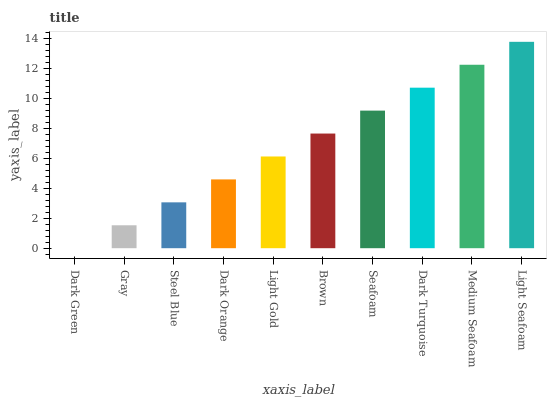Is Dark Green the minimum?
Answer yes or no. Yes. Is Light Seafoam the maximum?
Answer yes or no. Yes. Is Gray the minimum?
Answer yes or no. No. Is Gray the maximum?
Answer yes or no. No. Is Gray greater than Dark Green?
Answer yes or no. Yes. Is Dark Green less than Gray?
Answer yes or no. Yes. Is Dark Green greater than Gray?
Answer yes or no. No. Is Gray less than Dark Green?
Answer yes or no. No. Is Brown the high median?
Answer yes or no. Yes. Is Light Gold the low median?
Answer yes or no. Yes. Is Seafoam the high median?
Answer yes or no. No. Is Medium Seafoam the low median?
Answer yes or no. No. 